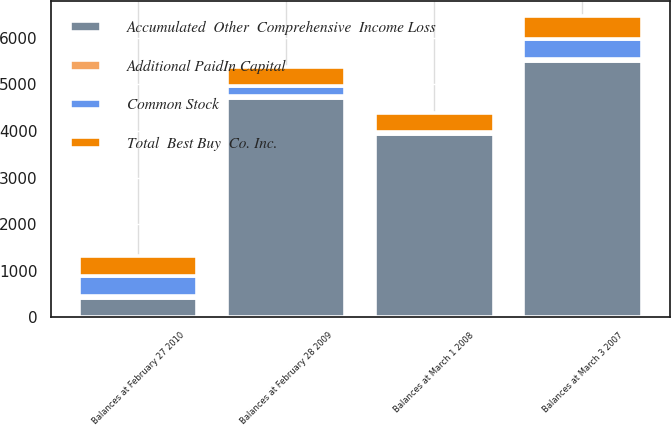Convert chart to OTSL. <chart><loc_0><loc_0><loc_500><loc_500><stacked_bar_chart><ecel><fcel>Balances at March 3 2007<fcel>Balances at March 1 2008<fcel>Balances at February 28 2009<fcel>Balances at February 27 2010<nl><fcel>Total  Best Buy  Co. Inc.<fcel>481<fcel>411<fcel>414<fcel>419<nl><fcel>Additional PaidIn Capital<fcel>48<fcel>41<fcel>41<fcel>42<nl><fcel>Common Stock<fcel>430<fcel>8<fcel>205<fcel>441<nl><fcel>Accumulated  Other  Comprehensive  Income Loss<fcel>5507<fcel>3933<fcel>4714<fcel>414<nl></chart> 